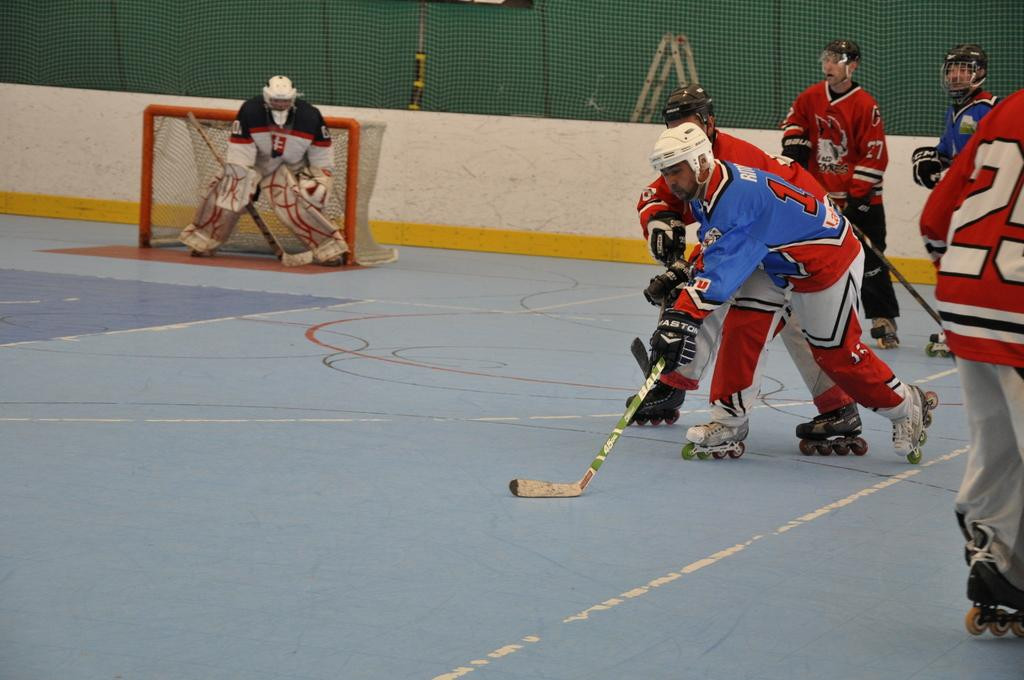What sport are the people playing in the image? The people are playing roller hockey in the image. On what surface is the roller hockey being played? The roller hockey is being played on the ground. What can be seen in the background of the image? There is a wall and a fencing net in the background of the image. What type of rake is being used to hit the roller hockey ball in the image? There is no rake present in the image; the people are using hockey sticks to play roller hockey. Can you see any beds in the image? There are no beds present in the image; it features people playing roller hockey on the ground. 